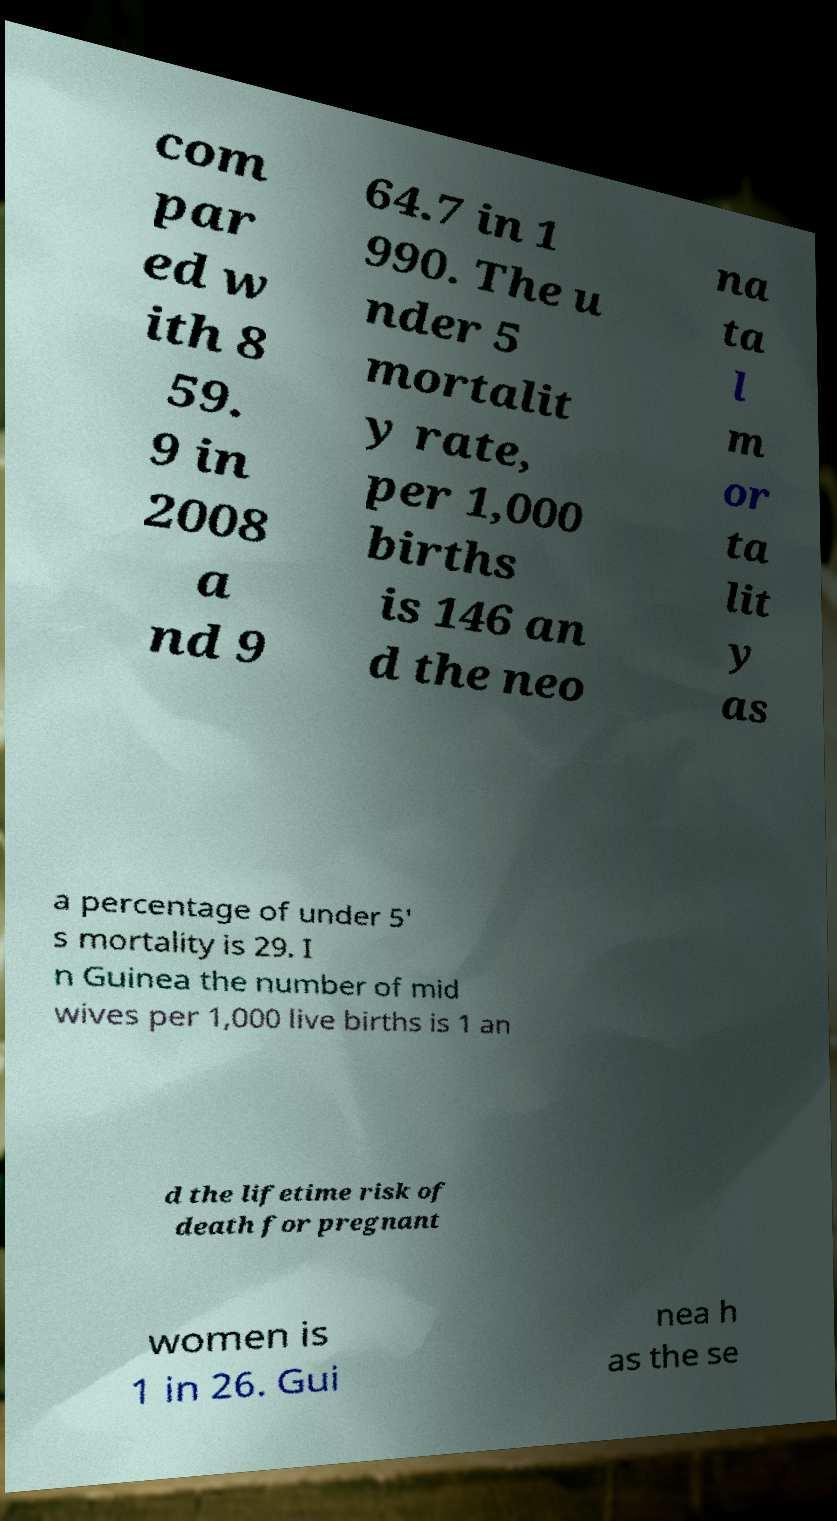There's text embedded in this image that I need extracted. Can you transcribe it verbatim? com par ed w ith 8 59. 9 in 2008 a nd 9 64.7 in 1 990. The u nder 5 mortalit y rate, per 1,000 births is 146 an d the neo na ta l m or ta lit y as a percentage of under 5' s mortality is 29. I n Guinea the number of mid wives per 1,000 live births is 1 an d the lifetime risk of death for pregnant women is 1 in 26. Gui nea h as the se 